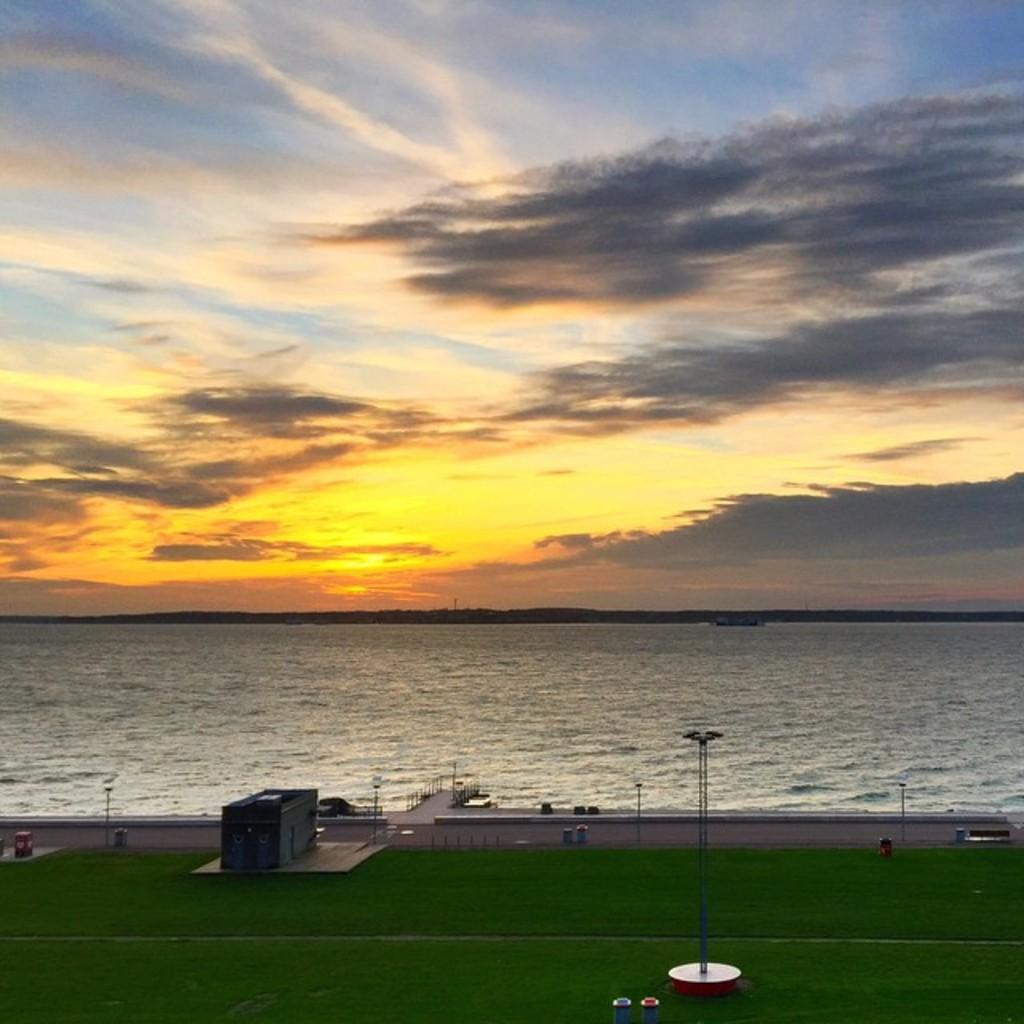Could you give a brief overview of what you see in this image? In this image I can see the ground. To the side of the ground I can see the container and the bridge. To the side of the bridge there are water. In the background there are clouds and the sky. 